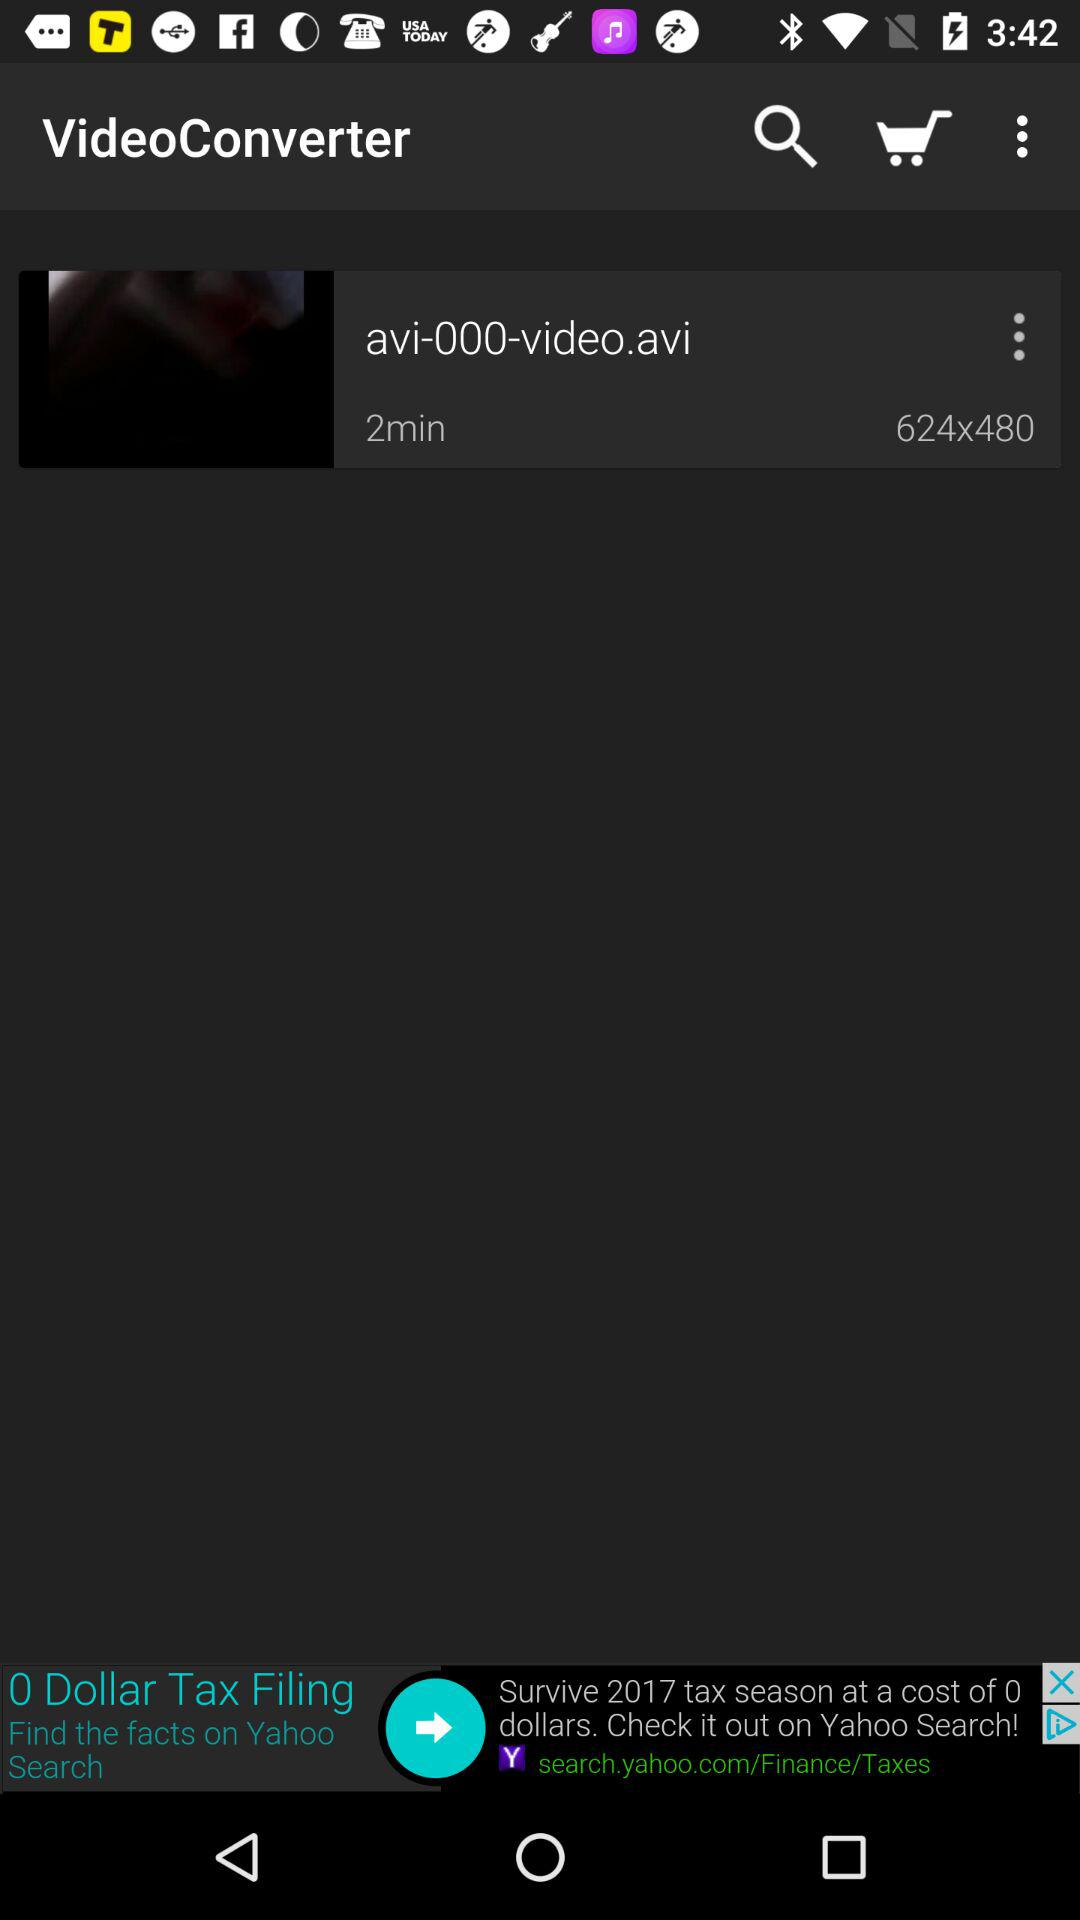What is the time duration of this video? The time duration is 2 minutes. 